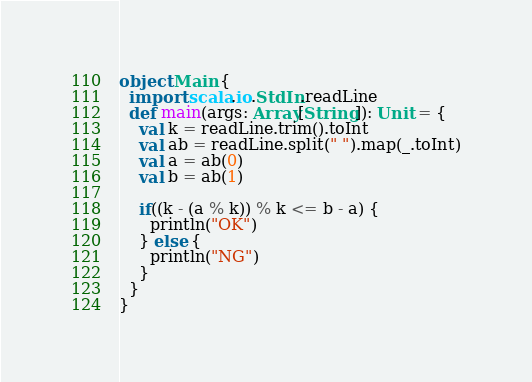Convert code to text. <code><loc_0><loc_0><loc_500><loc_500><_Scala_>object Main {
  import scala.io.StdIn.readLine
  def main(args: Array[String]): Unit = {
    val k = readLine.trim().toInt
    val ab = readLine.split(" ").map(_.toInt)
    val a = ab(0)
    val b = ab(1)

    if((k - (a % k)) % k <= b - a) {
      println("OK")
    } else {
      println("NG")
    }
  }
}
</code> 